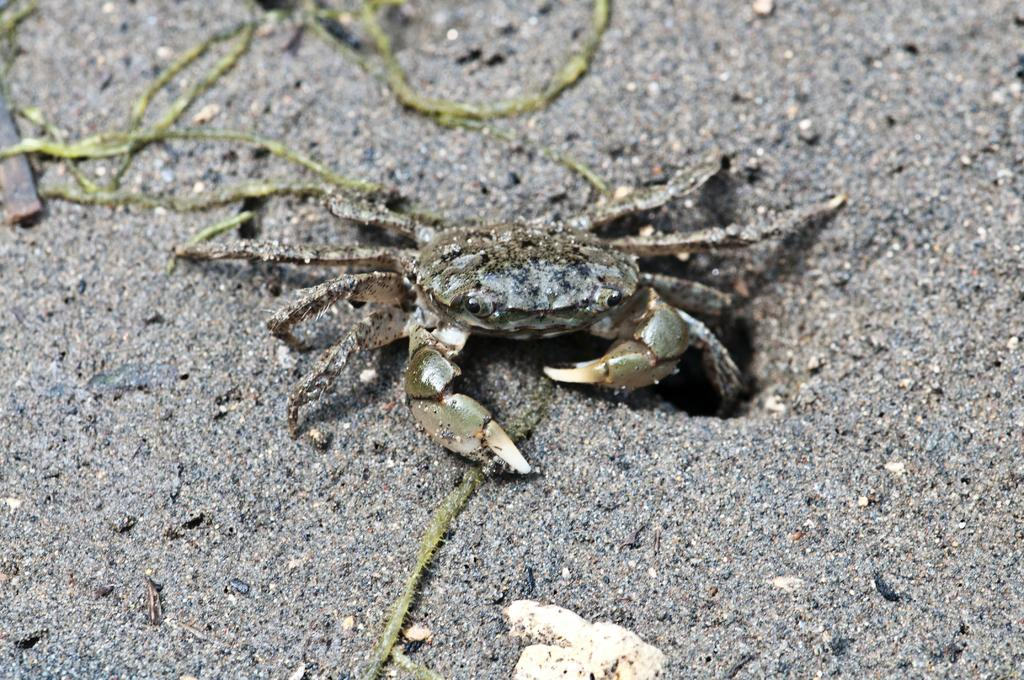What is the main subject of the image? The main subject of the image is a freshwater crab. Where is the crab located in the image? The crab is present on the ground in the image. What type of health advice can be seen in the image? There is no health advice present in the image; it features a freshwater crab on the ground. What type of police equipment can be seen in the image? There is no police equipment present in the image; it features a freshwater crab on the ground. 